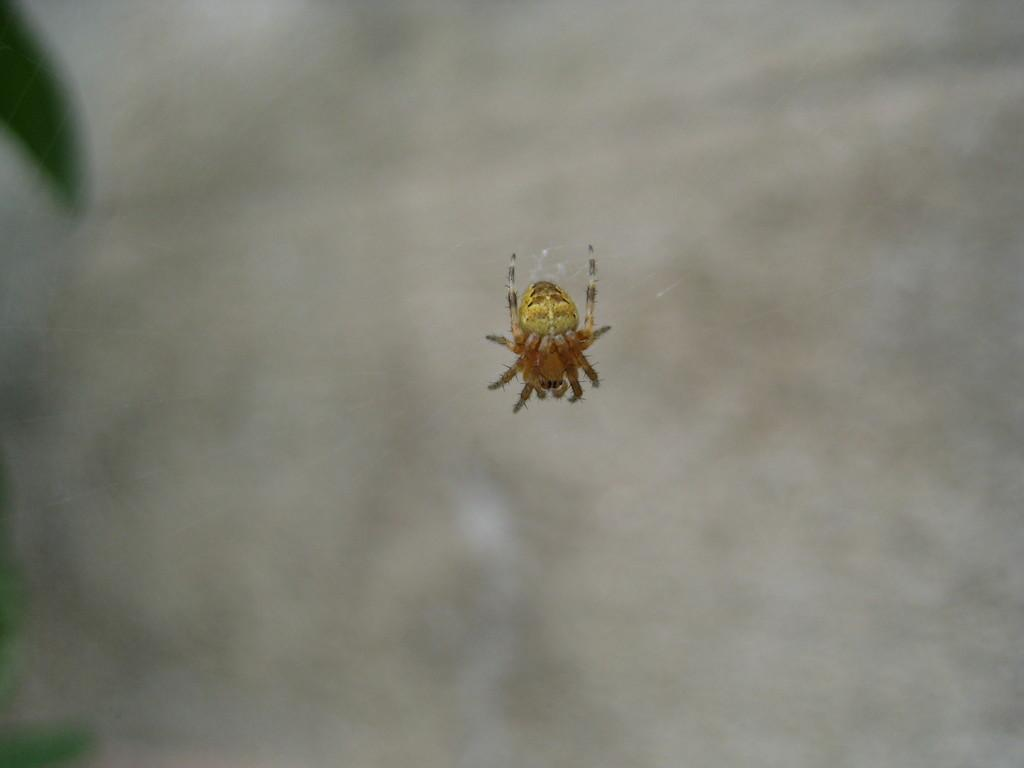What is the main subject of the picture? The main subject of the picture is a spider. Where is the spider located in the image? The spider is in the center of the picture. What is the spider doing in the image? The spider is in its web. Can you describe the background of the image? The background of the image is blurred. What type of plantation can be seen in the background of the image? There is no plantation present in the image; the background is blurred. Can you read the letter that the spider is holding in the image? There is no letter present in the image; the spider is in its web. 